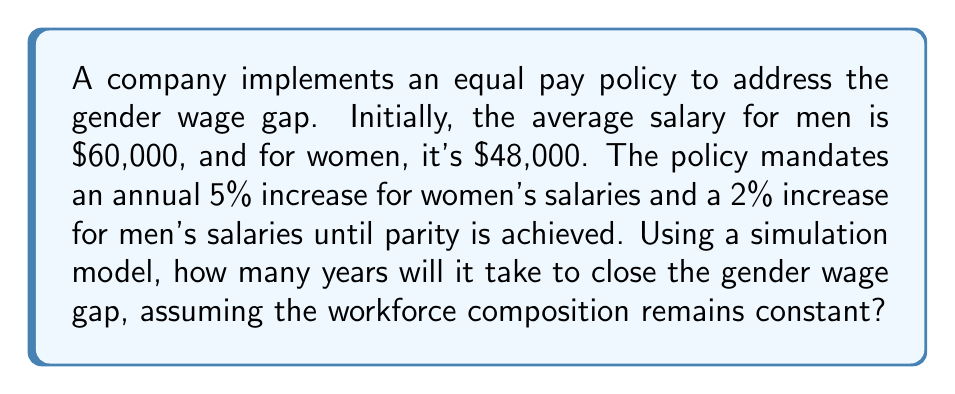Can you answer this question? Let's approach this step-by-step:

1) Let $M_n$ and $W_n$ be the salaries for men and women respectively in year $n$.

2) Initial conditions:
   $M_0 = 60000$
   $W_0 = 48000$

3) For each year, we can calculate:
   $M_n = M_{n-1} \times 1.02$
   $W_n = W_{n-1} \times 1.05$

4) We need to find $n$ where $W_n \geq M_n$

5) Let's simulate this:

   Year 0: $M_0 = 60000$, $W_0 = 48000$
   Year 1: $M_1 = 60000 \times 1.02 = 61200$, $W_1 = 48000 \times 1.05 = 50400$
   Year 2: $M_2 = 61200 \times 1.02 = 62424$, $W_2 = 50400 \times 1.05 = 52920$
   Year 3: $M_3 = 62424 \times 1.02 = 63672.48$, $W_3 = 52920 \times 1.05 = 55566$
   Year 4: $M_4 = 63672.48 \times 1.02 = 64945.93$, $W_4 = 55566 \times 1.05 = 58344.30$
   Year 5: $M_5 = 64945.93 \times 1.02 = 66244.85$, $W_5 = 58344.30 \times 1.05 = 61261.52$
   Year 6: $M_6 = 66244.85 \times 1.02 = 67569.75$, $W_6 = 61261.52 \times 1.05 = 64324.59$
   Year 7: $M_7 = 67569.75 \times 1.02 = 68921.14$, $W_7 = 64324.59 \times 1.05 = 67540.82$
   Year 8: $M_8 = 68921.14 \times 1.02 = 70299.56$, $W_8 = 67540.82 \times 1.05 = 70917.86$

6) We see that in Year 8, $W_8 > M_8$, so the gap closes in 8 years.
Answer: 8 years 